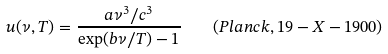Convert formula to latex. <formula><loc_0><loc_0><loc_500><loc_500>u ( \nu , T ) = \frac { a \nu ^ { 3 } / c ^ { 3 } } { \exp ( b \nu / T ) - 1 } \quad ( P l a n c k , 1 9 - X - 1 9 0 0 )</formula> 